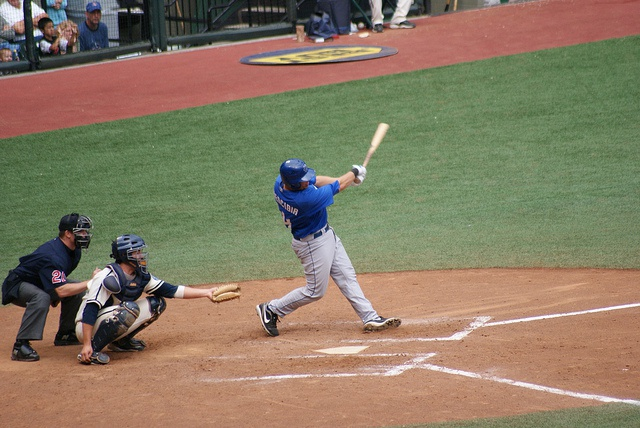Describe the objects in this image and their specific colors. I can see people in gray, darkgray, lightgray, navy, and black tones, people in gray, black, lightgray, and brown tones, people in gray, black, navy, and brown tones, people in gray, navy, black, and darkblue tones, and people in gray, lavender, black, brown, and darkgray tones in this image. 